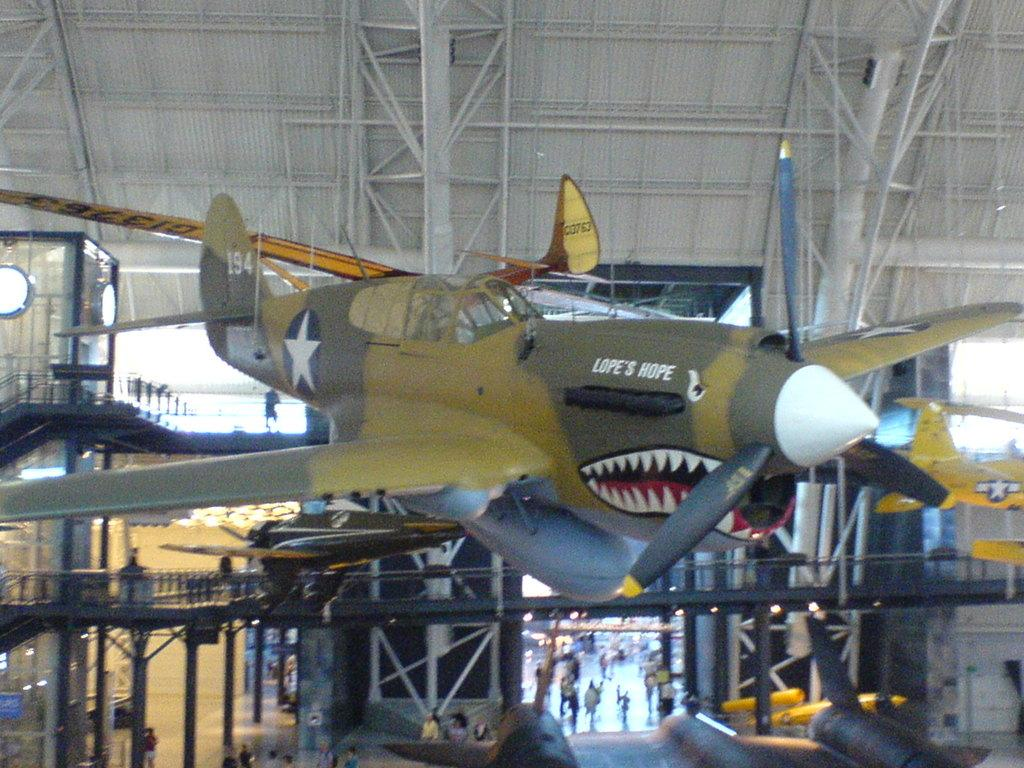<image>
Share a concise interpretation of the image provided. A Lope's Hope airplane suspended from the ceiling in a museum 